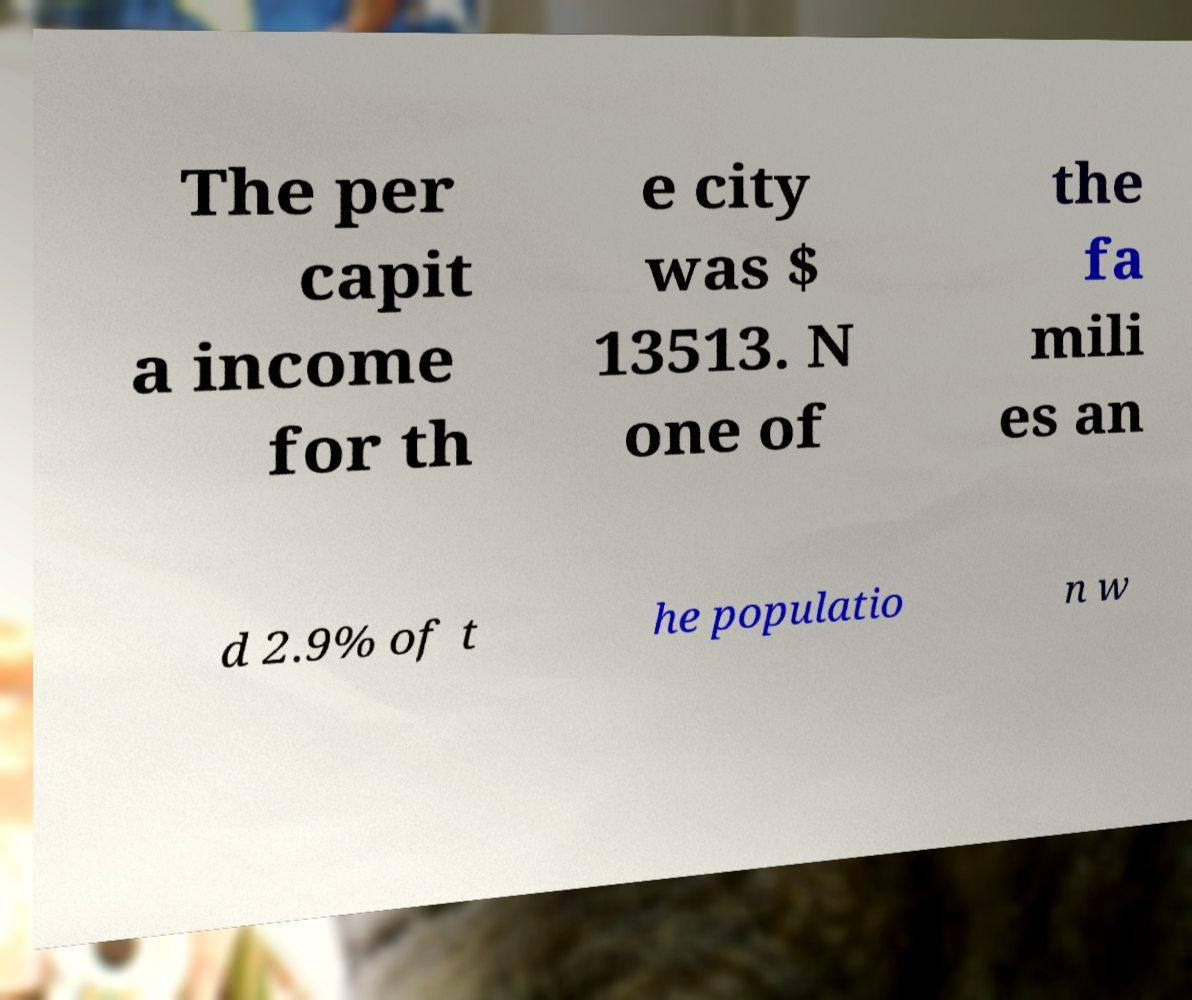Could you extract and type out the text from this image? The per capit a income for th e city was $ 13513. N one of the fa mili es an d 2.9% of t he populatio n w 